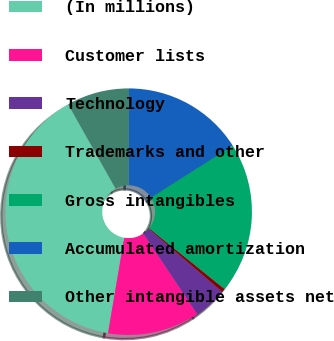Convert chart. <chart><loc_0><loc_0><loc_500><loc_500><pie_chart><fcel>(In millions)<fcel>Customer lists<fcel>Technology<fcel>Trademarks and other<fcel>Gross intangibles<fcel>Accumulated amortization<fcel>Other intangible assets net<nl><fcel>39.16%<fcel>12.07%<fcel>4.33%<fcel>0.47%<fcel>19.81%<fcel>15.94%<fcel>8.2%<nl></chart> 